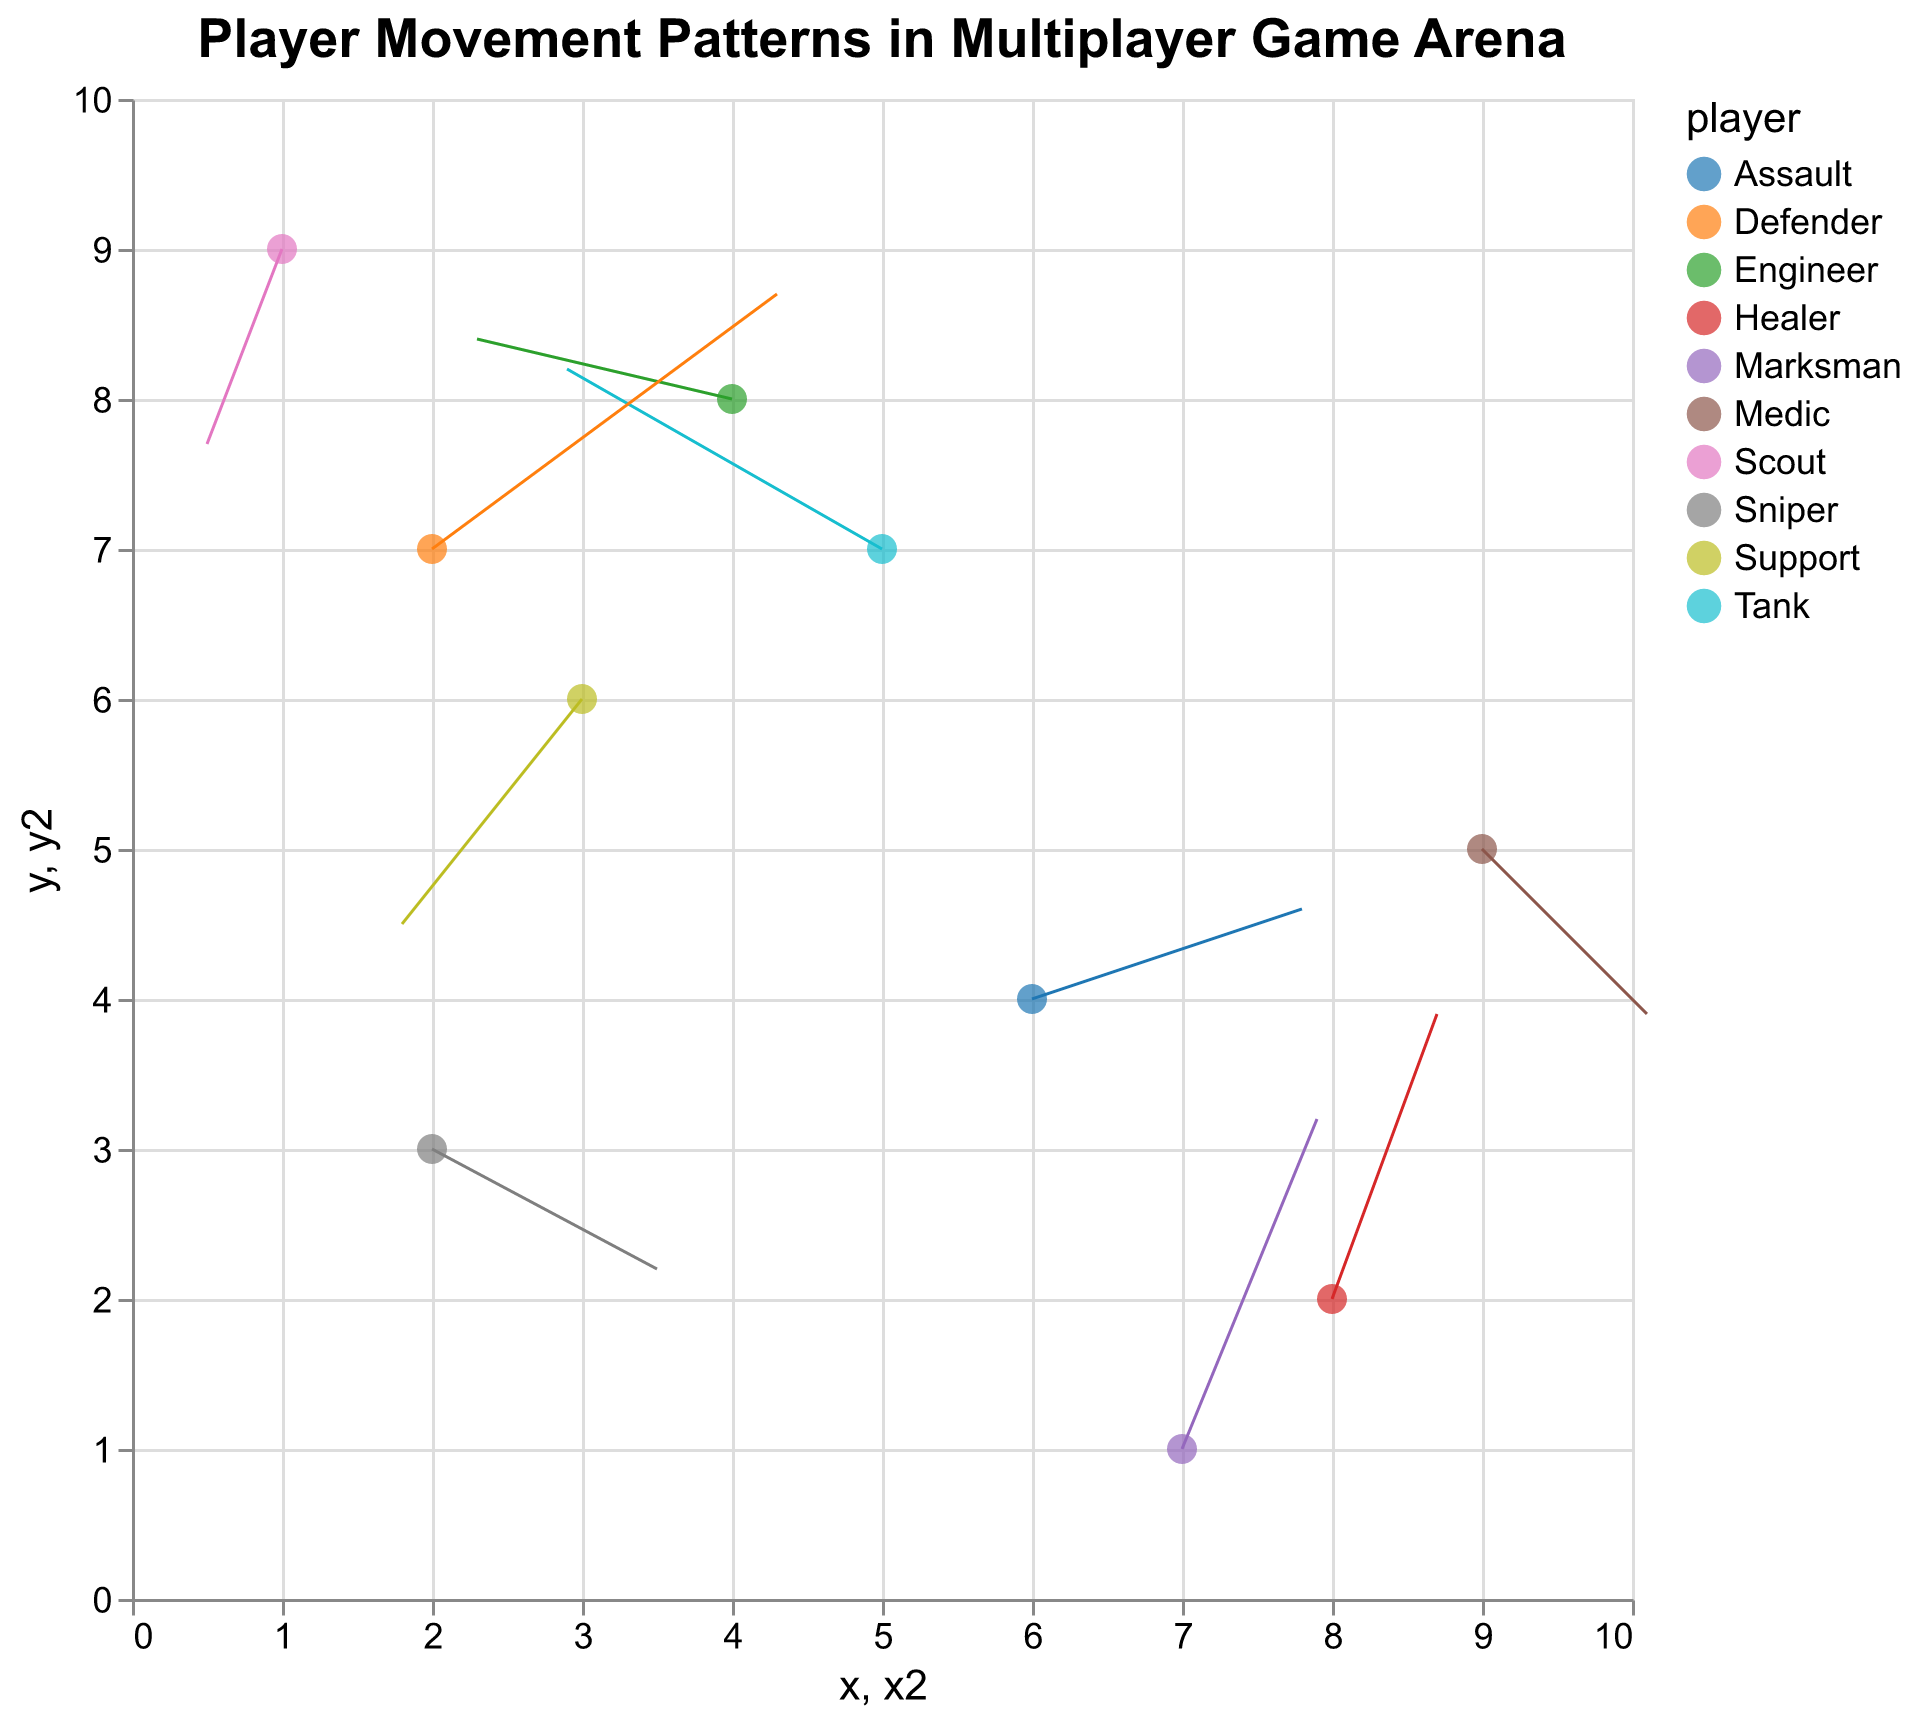What is the title of the plot? The title is displayed at the top of the figure in bold, large font, making it easy to read.
Answer: Player Movement Patterns in Multiplayer Game Arena How many player types are shown in the figure? Each player type is represented by a unique color, and their names appear in the legend or tooltips. By counting these distinct entries, we identify 10 player types.
Answer: 10 Which player has the longest movement vector? By visually inspecting the length of the arrows in the figure, the longest one appears to be from "Defender" at (2, 7) with vector (2.3, 1.7).
Answer: Defender Which player moves to the highest y-coordinate? The y-coordinate of a player's movement endpoint can be found by adding the `y` value to the `v` value. The player with the highest resultant y-coordinate is "Marksman" at (7, 1) moving with vector (0.9, 2.2) to y = 3.2 (1 + 2.2).
Answer: Marksman Which players move diagonally downward? Diagonally downward movement means both `u` (x-direction) and `v` (y-direction) are negative. By inspecting the figure, "Support" and "Scout" show diagonal downward patterns.
Answer: Support, Scout What is the sum of the initial x-coordinates of all players with a negative x-direction movement? First identify players with negative `u` values: Tank, Support, Engineer, Scout. Their x-coordinates are 5, 3, 4, 1. Summing these: 5 + 3 + 4 + 1 = 13.
Answer: 13 Which player shows a movement in the positive x-direction but negative y-direction? Checking the figure, the movement vector with a positive `u` and negative `v` is from "Sniper" at (2, 3) moving with vector (1.5, -0.8).
Answer: Sniper What is the average initial y-coordinate for players with positive y-direction movements (`v`) over 1? Identify players with `v` over 1: Tank, Healer, Marksman, Defender. Their y-coordinates are 7, 2, 1, 7. Average: (7 + 2 + 1 + 7) / 4 = 4.25.
Answer: 4.25 Between "Tank" and "Assault", who has a larger magnitude of movement vector? Calculate vector magnitudes: Tank's vector (-2.1, 1.2) and Assault's (1.8, 0.6). Magnitude formula √(u² + v²). Tank: √((-2.1)² + 1.2²) ≈ 2.4, Assault: √(1.8² + 0.6²) ≈ 1.9. Tank has a larger vector magnitude.
Answer: Tank 